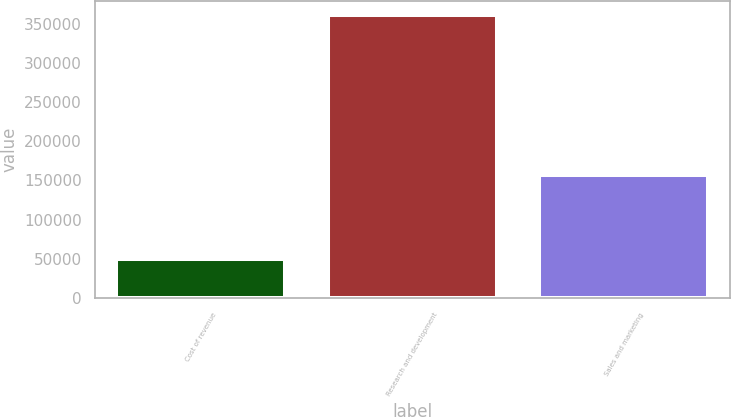Convert chart to OTSL. <chart><loc_0><loc_0><loc_500><loc_500><bar_chart><fcel>Cost of revenue<fcel>Research and development<fcel>Sales and marketing<nl><fcel>50536<fcel>360726<fcel>157263<nl></chart> 